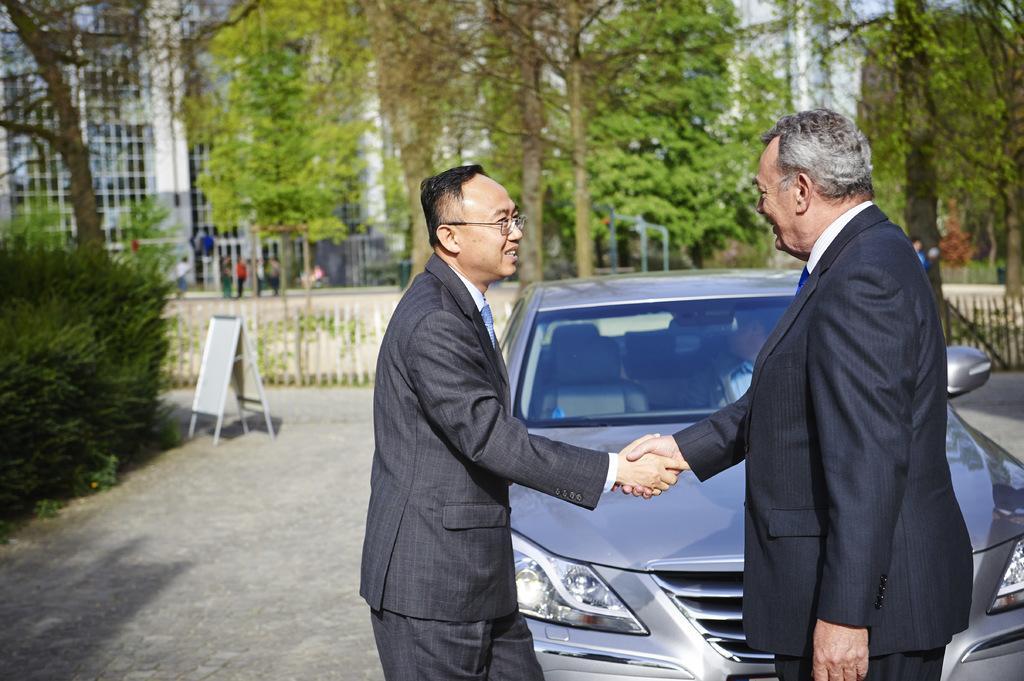In one or two sentences, can you explain what this image depicts? In this picture we can see two men shaking their hands. There is a car and a board on the path. We can see a plant on left side. There is some fencing from left to right. Few people are visible at the back. Some trees and buildings are visible in the background. 